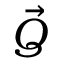<formula> <loc_0><loc_0><loc_500><loc_500>\vec { Q }</formula> 